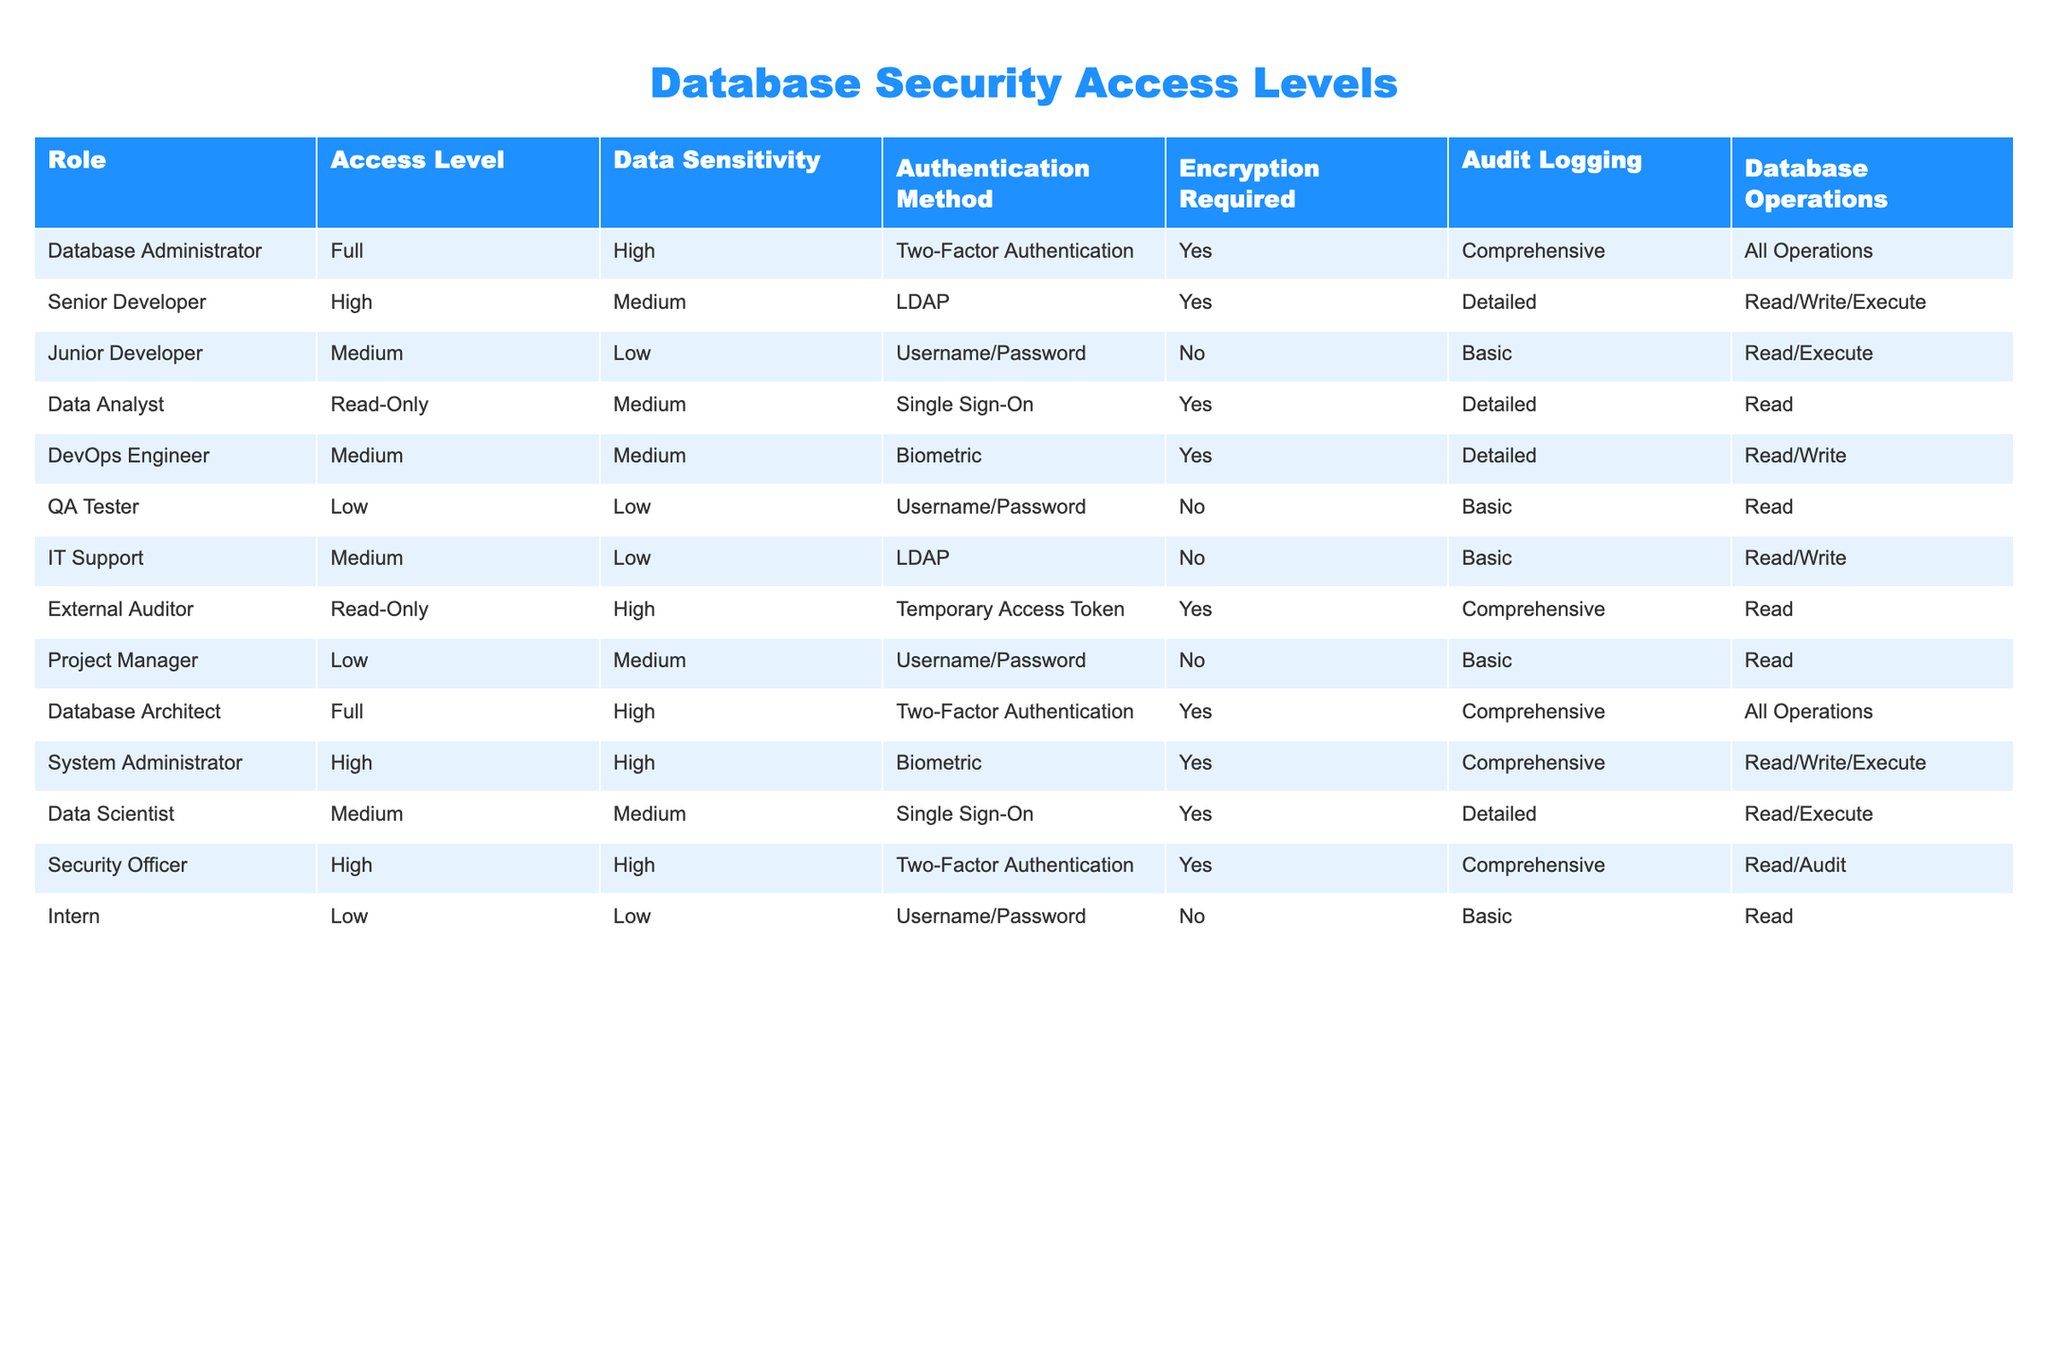What is the access level for a Data Analyst? The table indicates the access level of the Data Analyst is "Read-Only." This information is directly available in the corresponding row for the Data Analyst.
Answer: Read-Only Which roles require Two-Factor Authentication? The table lists the roles that require Two-Factor Authentication: Database Administrator, Database Architect, System Administrator, and Security Officer. This can be determined by filtering the rows where the Authentication Method column has "Two-Factor Authentication."
Answer: Database Administrator, Database Architect, System Administrator, Security Officer How many roles have a High access level? By inspecting the table, the roles with High access level are: Senior Developer, System Administrator, and Security Officer. Thus, there are three roles in total that have a High access level.
Answer: 3 Is Encryption required for the role of IT Support? The table clearly shows that IT Support does not require Encryption, as indicated by the "No" in the Encryption Required column for this role.
Answer: No What is the average data sensitivity level across all roles? To find the average data sensitivity, we assign numerical values (High=3, Medium=2, Low=1) to each sensitivity level. We count: High (6), Medium (5), and Low (4). The total score is 6*3 + 5*2 + 4*1 = 18 + 10 + 4 = 32. There are 15 roles, so the average is 32/15 ≈ 2.13, which corresponds to Medium on a scale from 1 to 3.
Answer: Medium What database operations can a Junior Developer perform? The Junior Developer role is allowed to perform Read and Execute operations. This is directly listed in the Database Operations column corresponding to this role.
Answer: Read/Execute Are all roles required to have Audit Logging enabled? Looking at the table, it is evident that not all roles require Audit Logging. Specifically, roles such as Junior Developer, QA Tester, IT Support, and Intern have "Basic" or do not require Audit Logging at all. Therefore, the answer is no.
Answer: No Which authentication methods are used by roles that have both high access level and high data sensitivity? The roles that meet both criteria are the Database Administrator and the System Administrator. The authentication methods for these roles are "Two-Factor Authentication" and "Biometric," respectively. Therefore, the unique methods are Two-Factor and Biometric.
Answer: Two-Factor, Biometric 